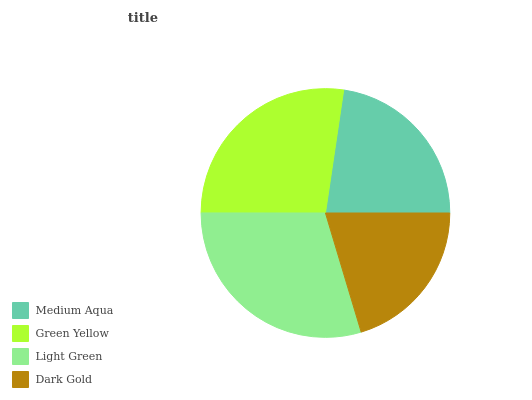Is Dark Gold the minimum?
Answer yes or no. Yes. Is Light Green the maximum?
Answer yes or no. Yes. Is Green Yellow the minimum?
Answer yes or no. No. Is Green Yellow the maximum?
Answer yes or no. No. Is Green Yellow greater than Medium Aqua?
Answer yes or no. Yes. Is Medium Aqua less than Green Yellow?
Answer yes or no. Yes. Is Medium Aqua greater than Green Yellow?
Answer yes or no. No. Is Green Yellow less than Medium Aqua?
Answer yes or no. No. Is Green Yellow the high median?
Answer yes or no. Yes. Is Medium Aqua the low median?
Answer yes or no. Yes. Is Light Green the high median?
Answer yes or no. No. Is Dark Gold the low median?
Answer yes or no. No. 